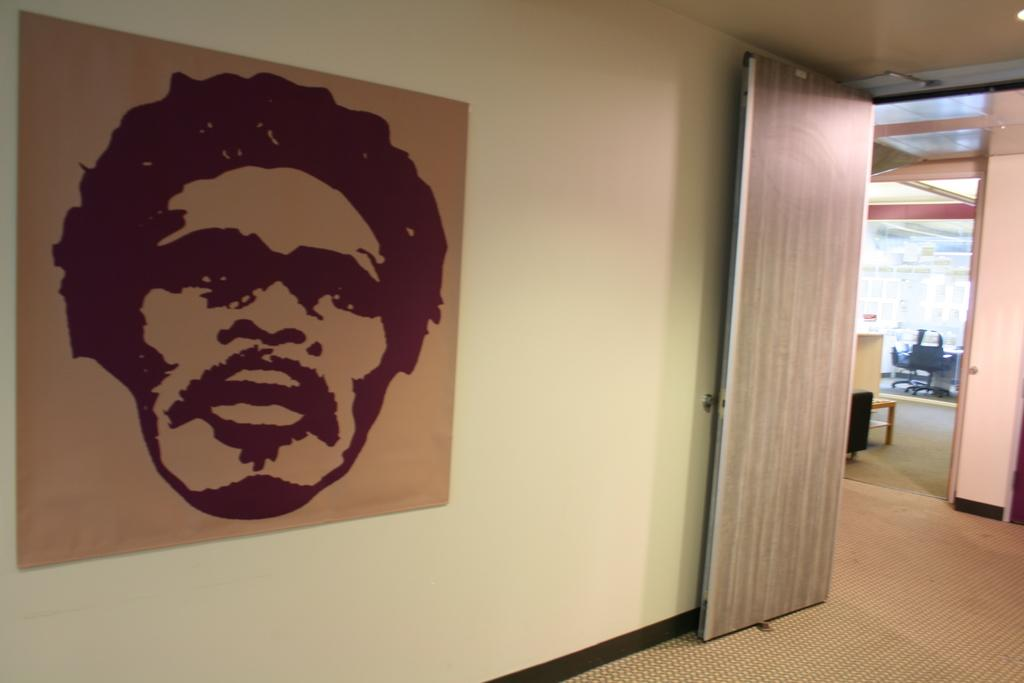What can be seen on the left side of the image? There is a sketch of a man's face on the wall in the left side of the image. What is located on the right side of the image? There is a door in the right side of the image. What type of religious exchange is happening in the image? There is no religious exchange happening in the image; it only features a sketch of a man's face and a door. What kind of shoe is the man wearing in the image? There is no man or shoe present in the image; it only features a sketch of a man's face and a door. 